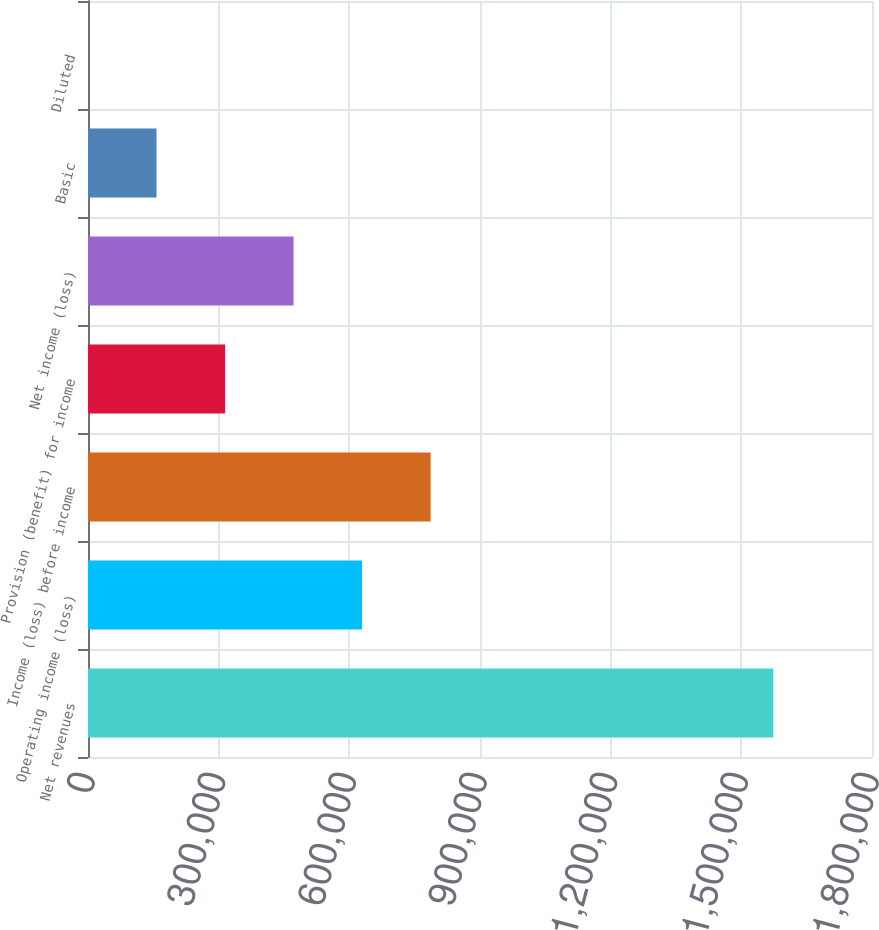Convert chart to OTSL. <chart><loc_0><loc_0><loc_500><loc_500><bar_chart><fcel>Net revenues<fcel>Operating income (loss)<fcel>Income (loss) before income<fcel>Provision (benefit) for income<fcel>Net income (loss)<fcel>Basic<fcel>Diluted<nl><fcel>1.57323e+06<fcel>629294<fcel>786617<fcel>314647<fcel>471970<fcel>157324<fcel>0.87<nl></chart> 